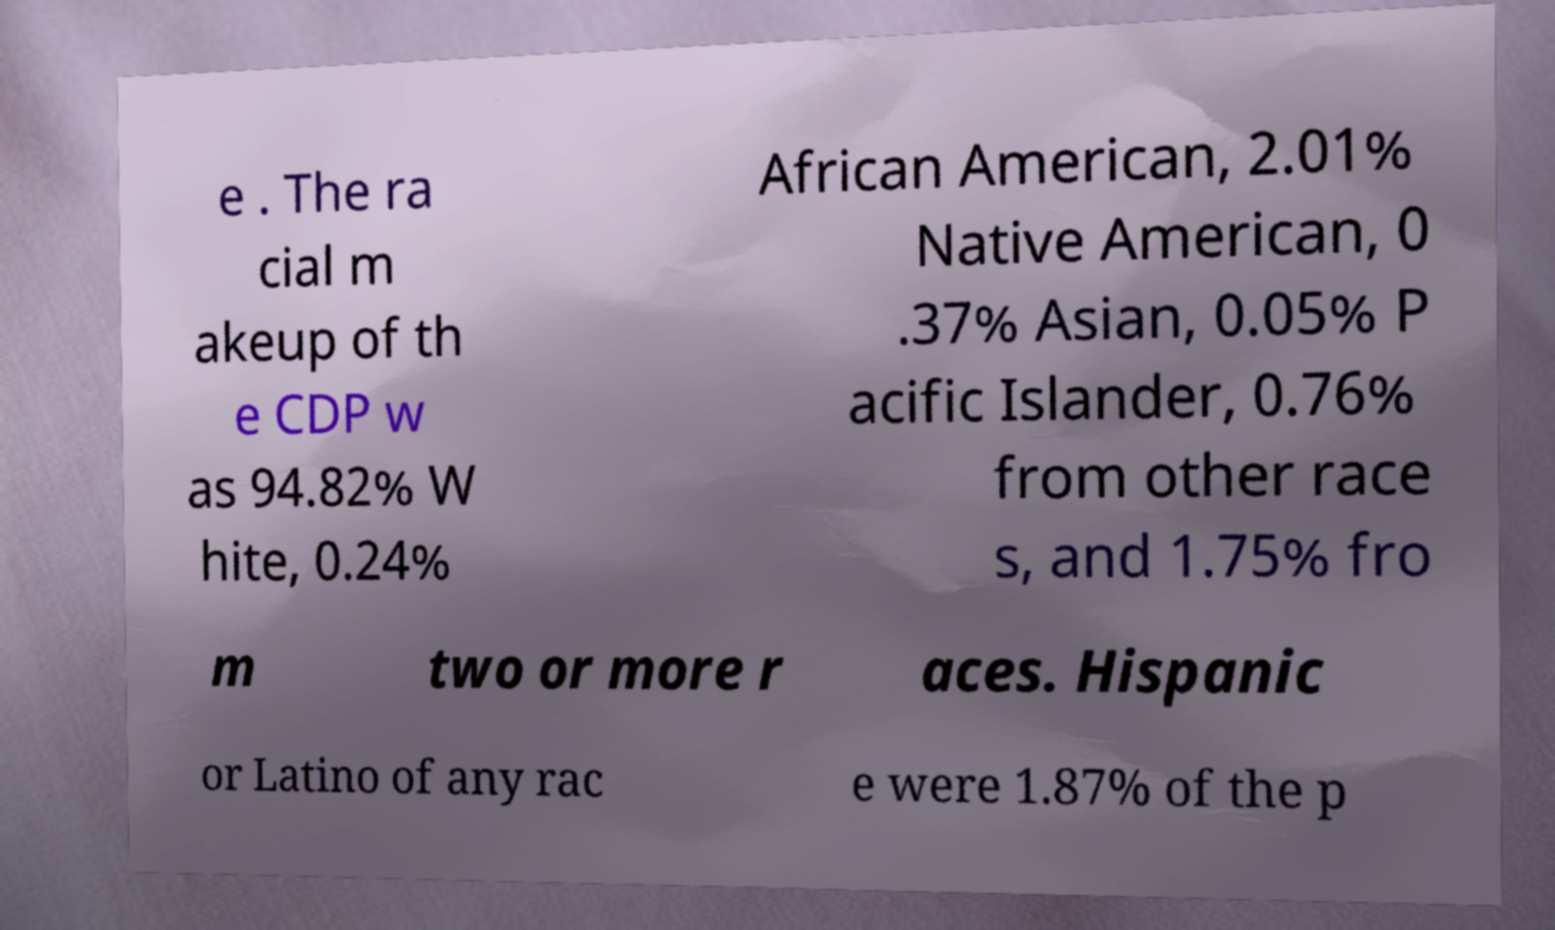What messages or text are displayed in this image? I need them in a readable, typed format. e . The ra cial m akeup of th e CDP w as 94.82% W hite, 0.24% African American, 2.01% Native American, 0 .37% Asian, 0.05% P acific Islander, 0.76% from other race s, and 1.75% fro m two or more r aces. Hispanic or Latino of any rac e were 1.87% of the p 